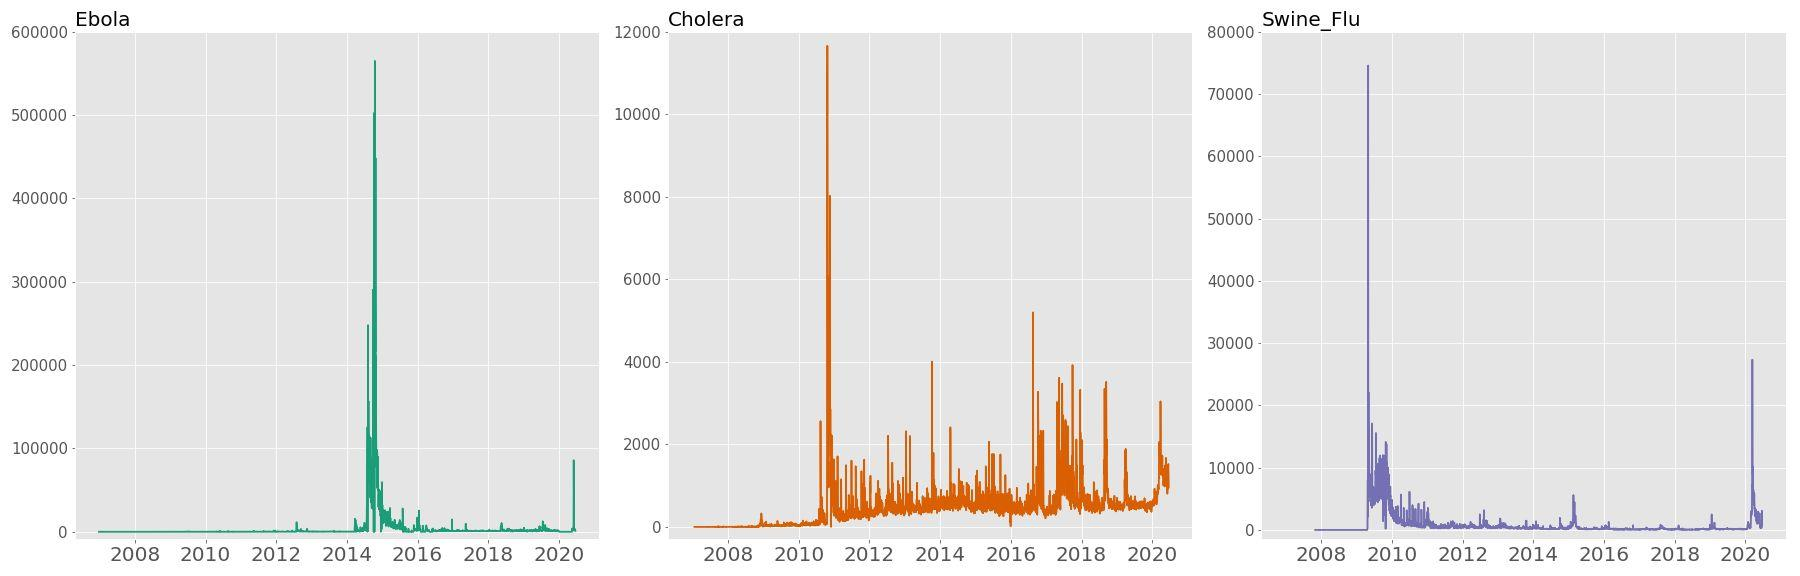Which range of years shows the most variation in search frequency for Ebola? A) 2008 - 2010 B) 2010 - 2012 C) 2012 - 2014 D) 2016 - 2018 Upon examining the search frequency graph for Ebola, we can observe a striking peak in queries between 2012 and 2014, coinciding with the significant Ebola outbreak during that period. This surge in search activity indicates heightened public interest and concern as the outbreak unfolded, making it the period with the most variation. Therefore, option C) 2012 - 2014 is the accurate choice, reflecting the graph's display of search intensity that escalates rapidly before tapering off, graphically encapsulating the pattern of heightened awareness during the epidemic's peak. 